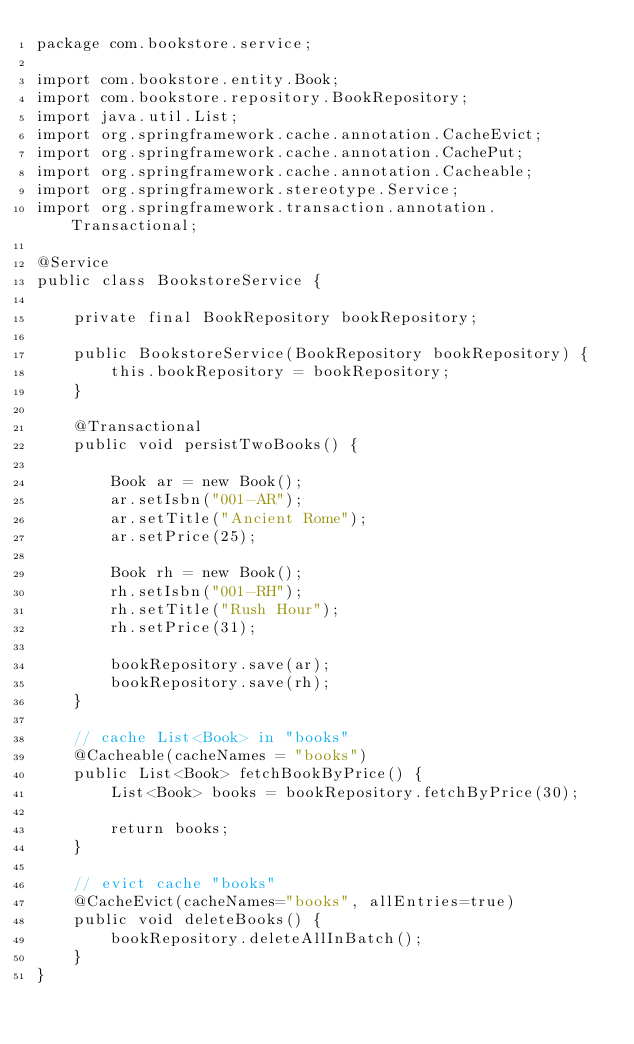<code> <loc_0><loc_0><loc_500><loc_500><_Java_>package com.bookstore.service;

import com.bookstore.entity.Book;
import com.bookstore.repository.BookRepository;
import java.util.List;
import org.springframework.cache.annotation.CacheEvict;
import org.springframework.cache.annotation.CachePut;
import org.springframework.cache.annotation.Cacheable;
import org.springframework.stereotype.Service;
import org.springframework.transaction.annotation.Transactional;

@Service
public class BookstoreService {

    private final BookRepository bookRepository;

    public BookstoreService(BookRepository bookRepository) {
        this.bookRepository = bookRepository;
    }

    @Transactional
    public void persistTwoBooks() {

        Book ar = new Book();
        ar.setIsbn("001-AR");
        ar.setTitle("Ancient Rome");
        ar.setPrice(25);

        Book rh = new Book();
        rh.setIsbn("001-RH");
        rh.setTitle("Rush Hour");
        rh.setPrice(31);

        bookRepository.save(ar);
        bookRepository.save(rh);
    }    
    
    // cache List<Book> in "books"
    @Cacheable(cacheNames = "books")
    public List<Book> fetchBookByPrice() {
        List<Book> books = bookRepository.fetchByPrice(30);
        
        return books;
    }       

    // evict cache "books"
    @CacheEvict(cacheNames="books", allEntries=true)
    public void deleteBooks() {
        bookRepository.deleteAllInBatch();
    }
}
</code> 